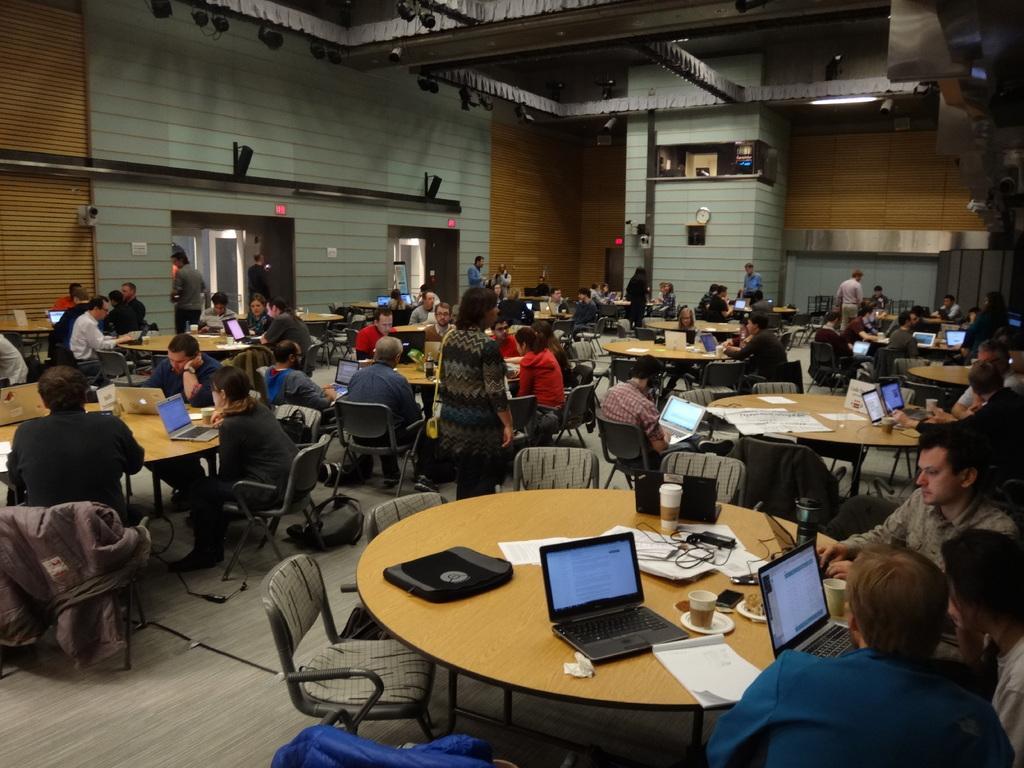In one or two sentences, can you explain what this image depicts? In this image, There are some tables which are in yellow color and on that tables there are some laptops which are in black color, There are some people sitting on the chairs around the tables, In the background there is a wall which white and black color, In the top there are some lights which are in black color hanging. 